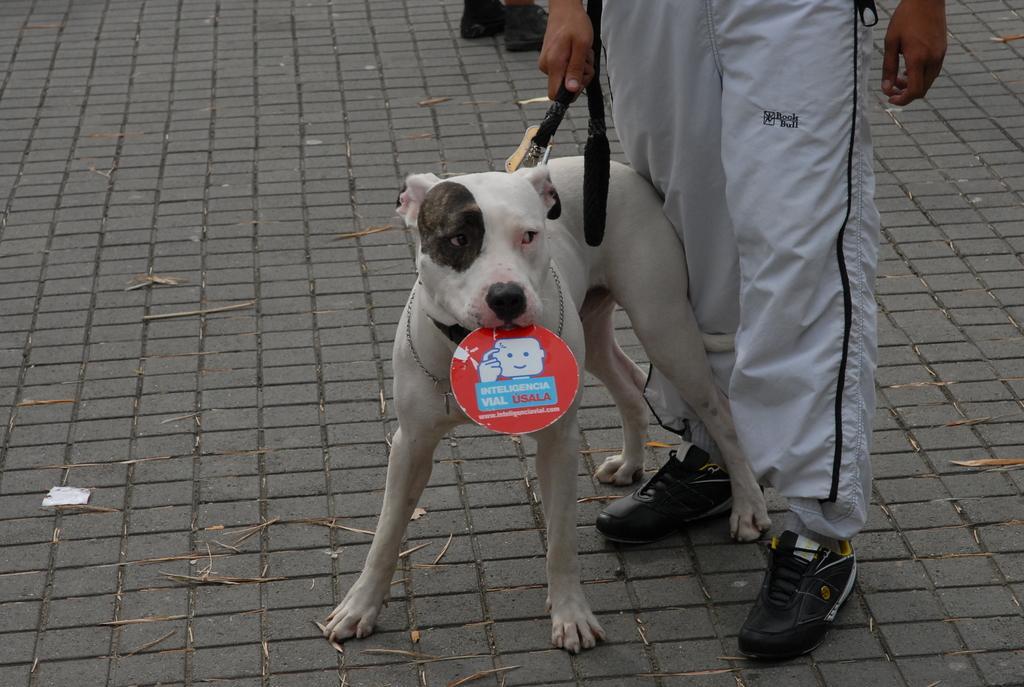How would you summarize this image in a sentence or two? In the picture we can find a person holding a dog. person is wearing a black shoe and track pant. And the dog is in white color it is holding something its mouth. 